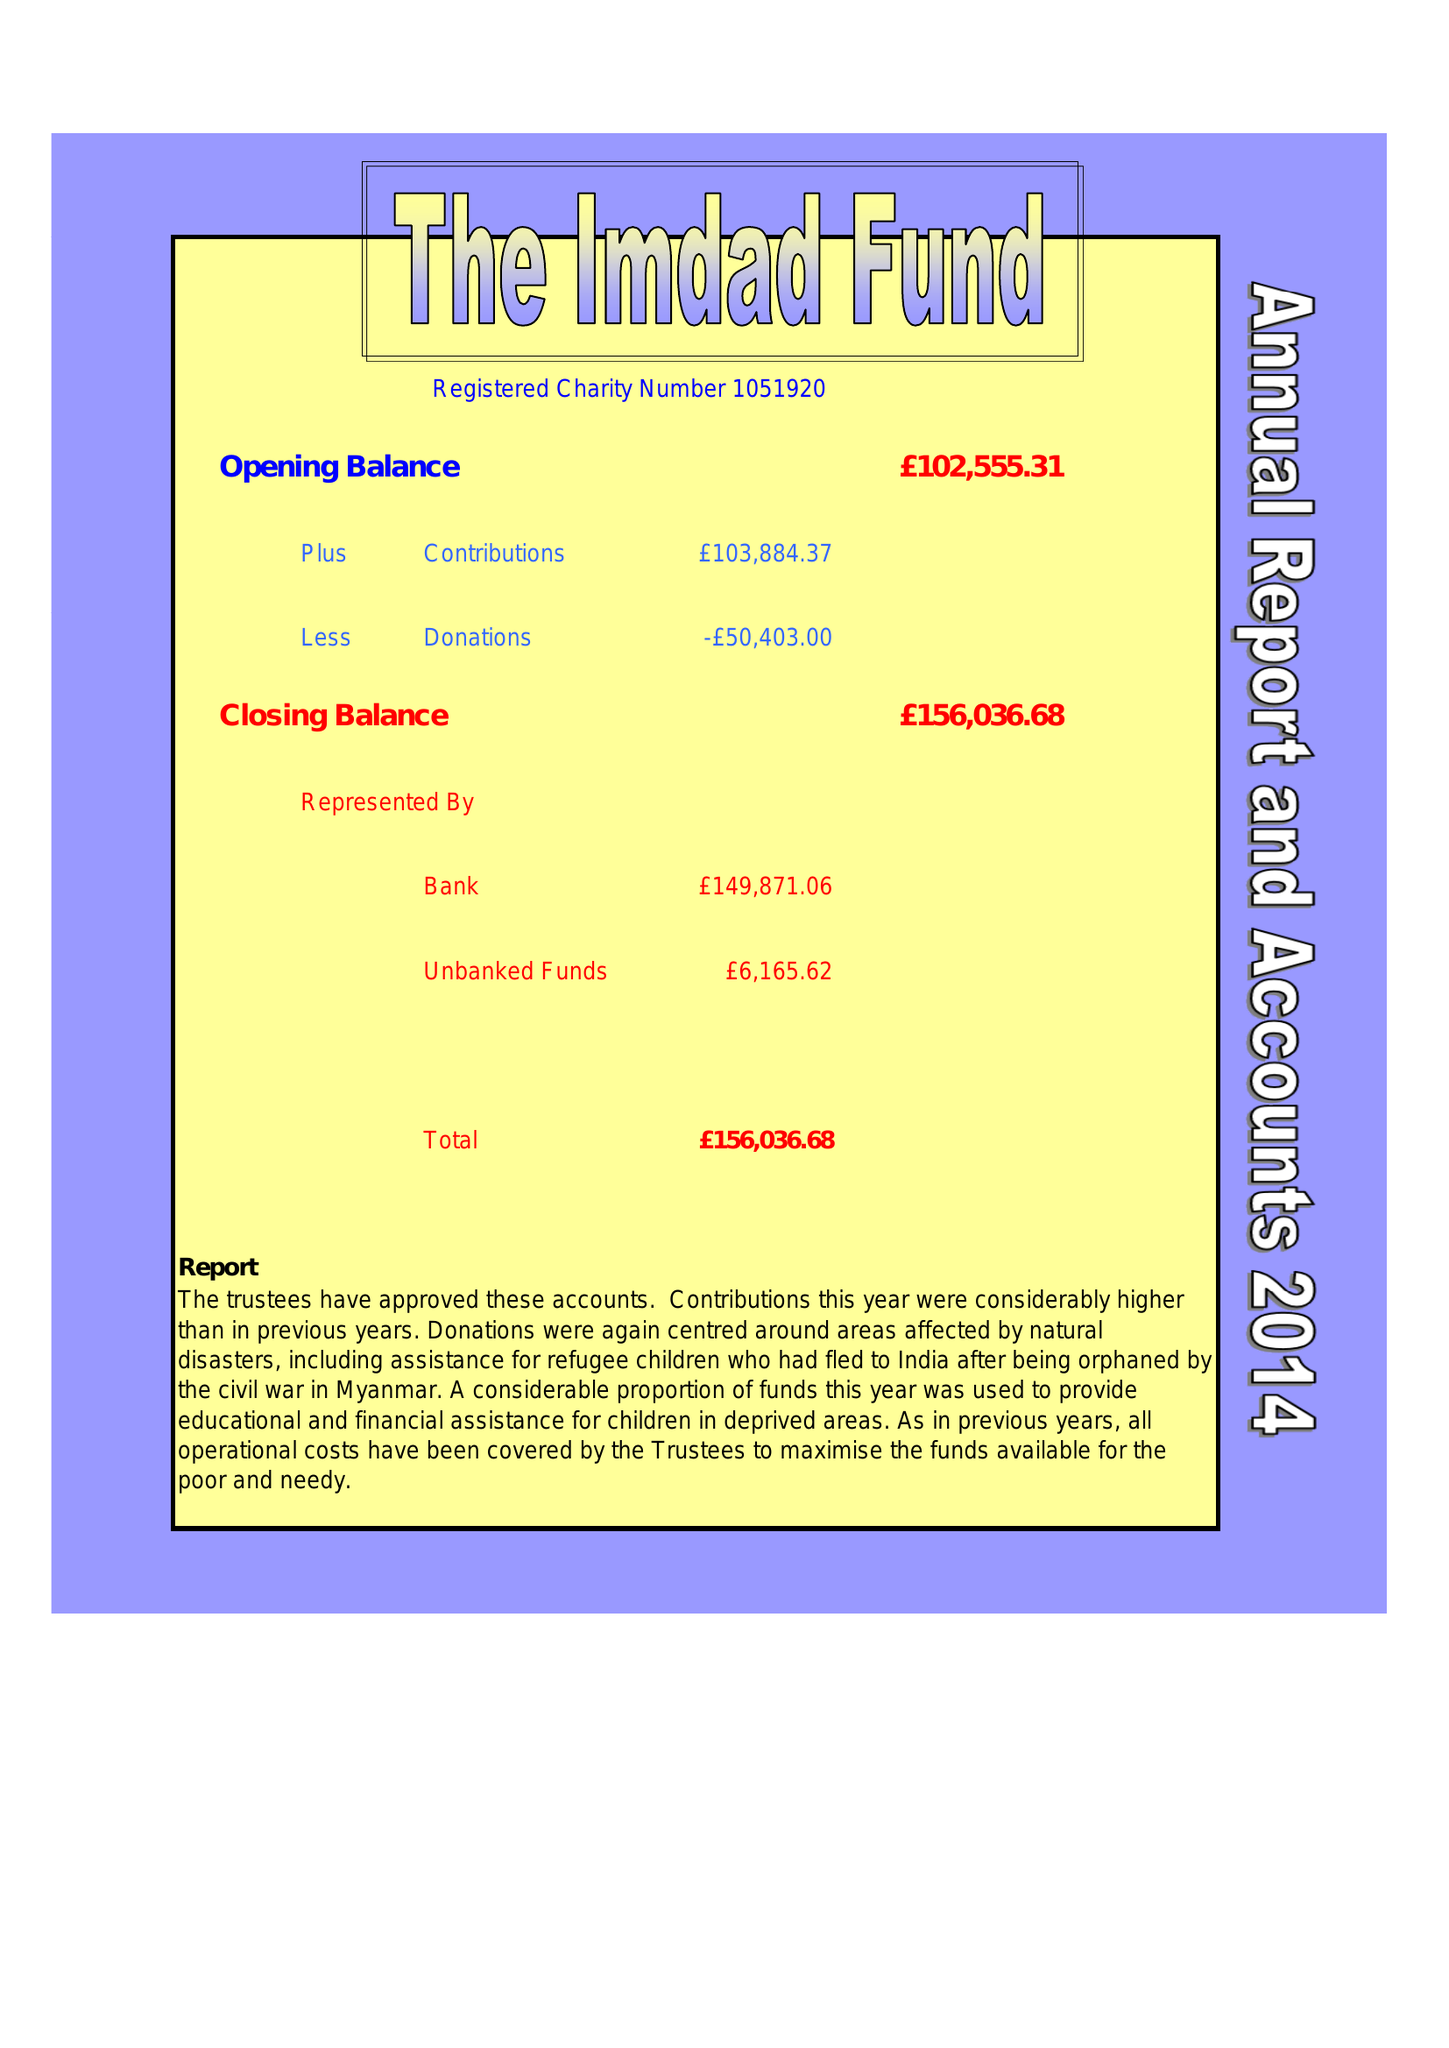What is the value for the income_annually_in_british_pounds?
Answer the question using a single word or phrase. 103884.37 